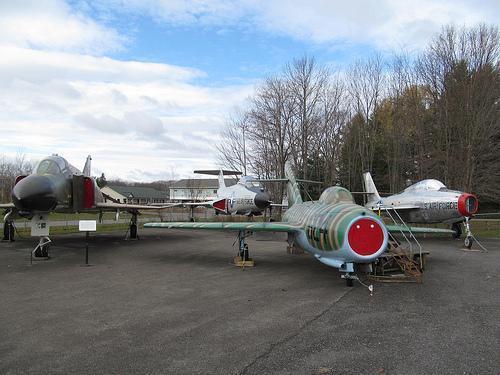How many vehicles are there?
Give a very brief answer. 4. How many people are visible?
Give a very brief answer. 0. How many planes are shown?
Give a very brief answer. 4. 